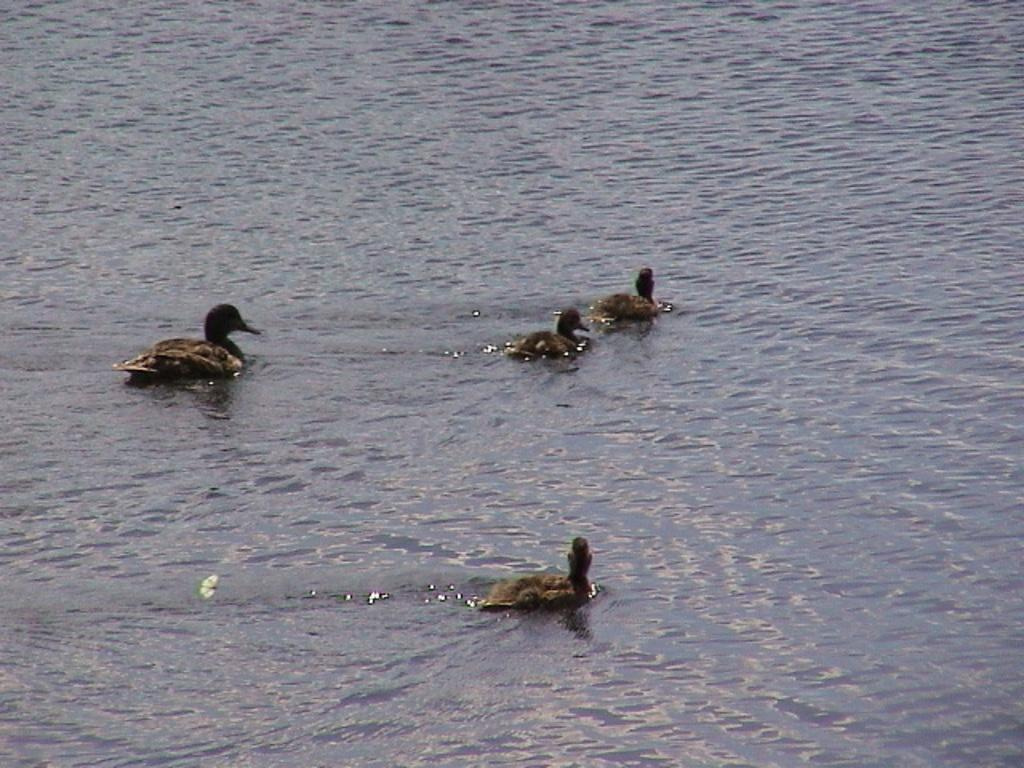How many ducks are present in the image? There are four ducks in the image. What are the ducks doing in the image? The ducks are swimming in the water. Can you describe the environment where the ducks are swimming? The water is likely in a pond or a lake. What type of toy can be seen floating near the ducks in the image? There is no toy present in the image; it only features four ducks swimming in the water. 